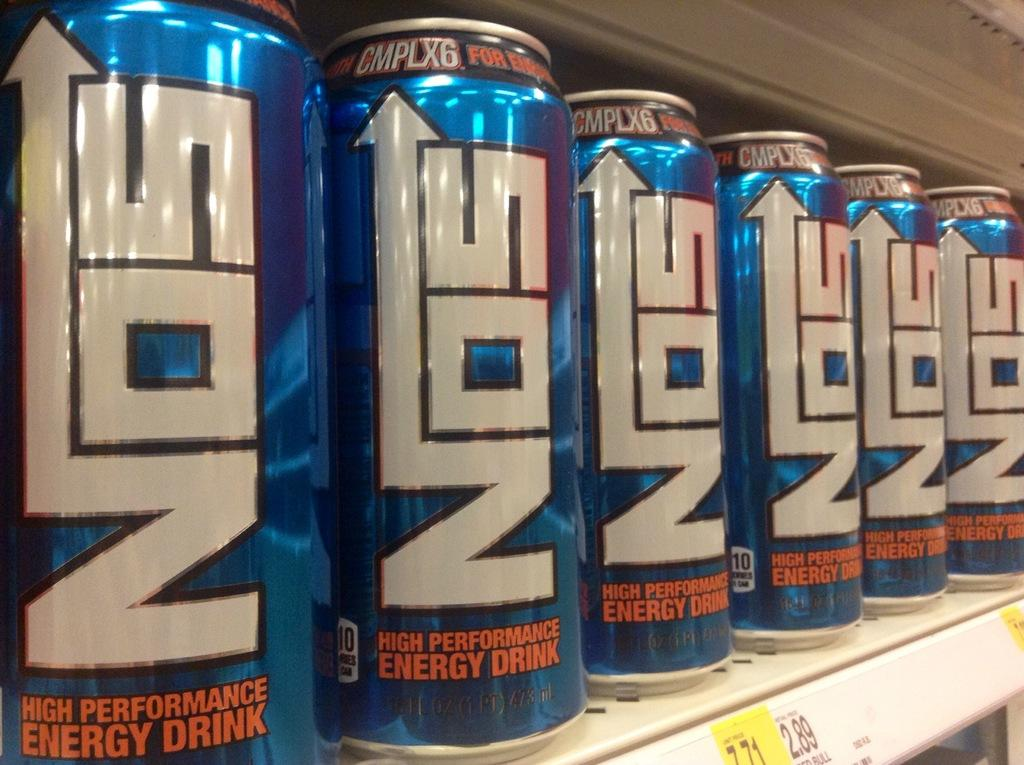Provide a one-sentence caption for the provided image. Several cans of NOS high performance energy drink are side by side on a shelf. 